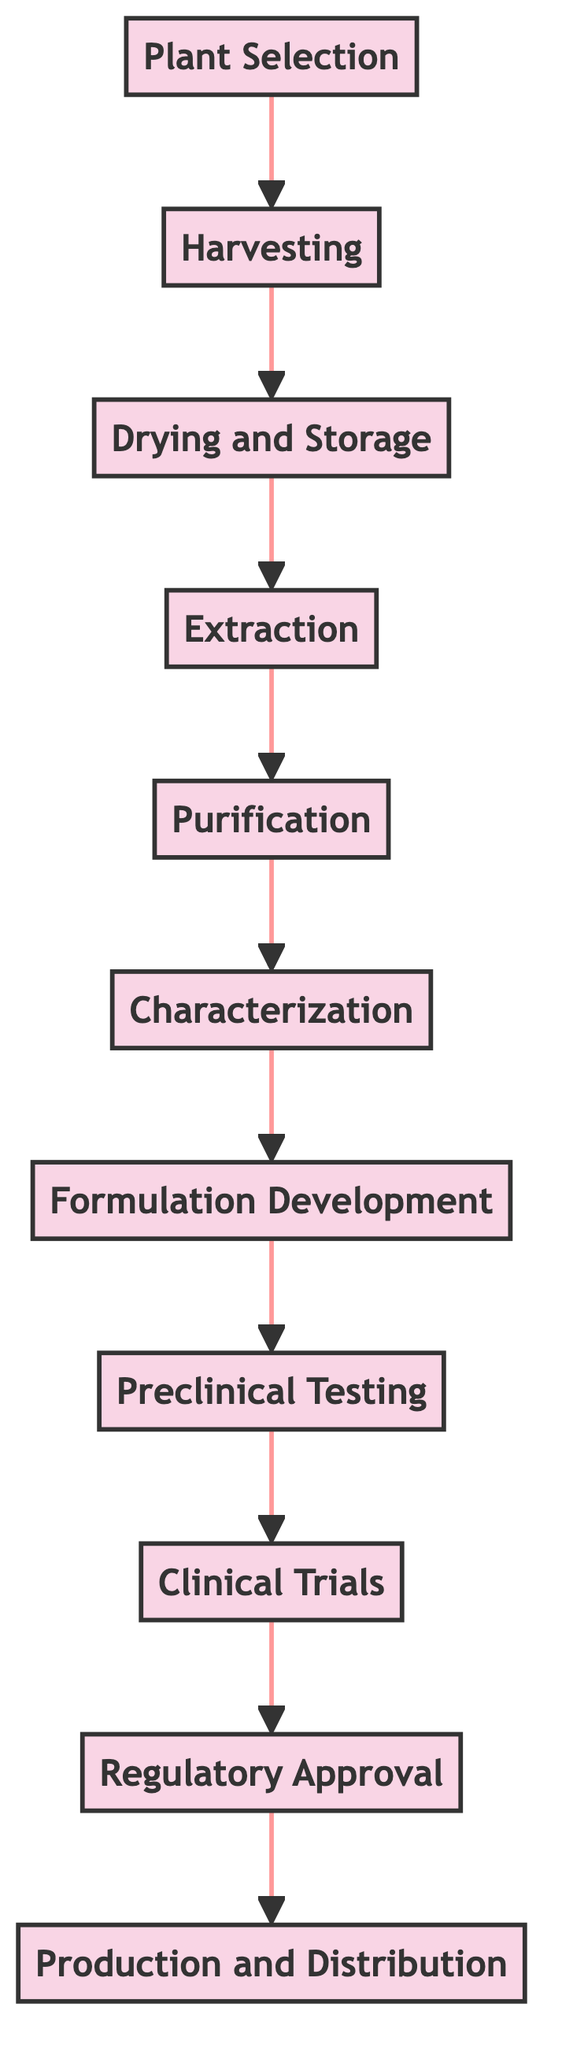What is the first step in formulating herbal medicines? The diagram indicates that the first step is "Plant Selection". This is positioned at the bottom of the flow chart, confirming it as the starting point of the process.
Answer: Plant Selection How many total steps are there in the process? By counting each individual step depicted in the flow chart, we can see that there are eleven steps total. The list of steps starts from "Plant Selection" and ends with "Production and Distribution".
Answer: Eleven What follows "Extraction" in the flow chart? Looking at the flow chart, the step that directly follows "Extraction" is "Purification". This can be seen clearly by tracing the arrow pointing upward from "Extraction".
Answer: Purification Which step involves testing on human volunteers? The diagram shows that the step involving testing on human volunteers is "Clinical Trials". This step appears after "Preclinical Testing" and before "Regulatory Approval".
Answer: Clinical Trials What is the last step in the process of formulating herbal medicines? The final step, as indicated by the topmost node of the flow chart, is "Production and Distribution". This confirms the culmination of the entire series of steps.
Answer: Production and Distribution Which two steps are connected by an arrow? Observing the diagram, "Formulation Development" and "Preclinical Testing" are connected by an arrow. This signifies the direct progression from one step to the other.
Answer: Formulation Development and Preclinical Testing What step comes after "Characterization"? According to the flow chart, the step that follows "Characterization" is "Formulation Development". The upward arrow leads directly from one to the other.
Answer: Formulation Development Which step entails analyzing the chemical structure? The step that entails analyzing the chemical structure and properties of the purified compounds is "Characterization". This is specifically detailed in the description associated with that step.
Answer: Characterization What is the purpose of "Regulatory Approval"? The purpose of "Regulatory Approval", as indicated in the diagram, is to submit the formulation data and clinical trial results to regulatory bodies for approval. This step is crucial for ensuring compliance and safety before the medicine can be produced and distributed.
Answer: Submit data for approval 